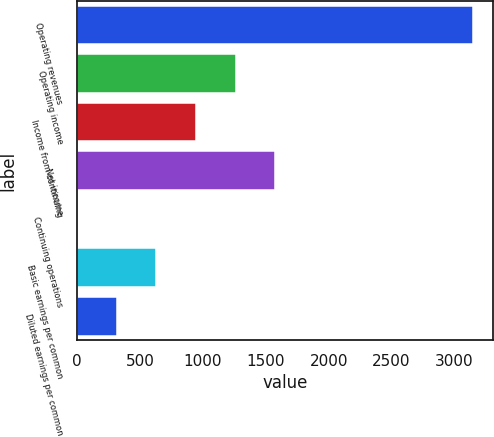<chart> <loc_0><loc_0><loc_500><loc_500><bar_chart><fcel>Operating revenues<fcel>Operating income<fcel>Income from continuing<fcel>Net income<fcel>Continuing operations<fcel>Basic earnings per common<fcel>Diluted earnings per common<nl><fcel>3149<fcel>1260.23<fcel>945.43<fcel>1575.03<fcel>1.03<fcel>630.63<fcel>315.83<nl></chart> 